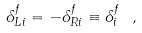Convert formula to latex. <formula><loc_0><loc_0><loc_500><loc_500>\delta _ { L i } ^ { f } = - \delta _ { R i } ^ { f } \equiv \delta _ { i } ^ { f } \ ,</formula> 